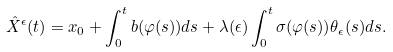Convert formula to latex. <formula><loc_0><loc_0><loc_500><loc_500>\hat { X } ^ { \epsilon } ( t ) & = x _ { 0 } + \int ^ { t } _ { 0 } b ( \varphi ( s ) ) d s + \lambda ( \epsilon ) \int ^ { t } _ { 0 } \sigma ( \varphi ( s ) ) \theta _ { \epsilon } ( s ) d s .</formula> 